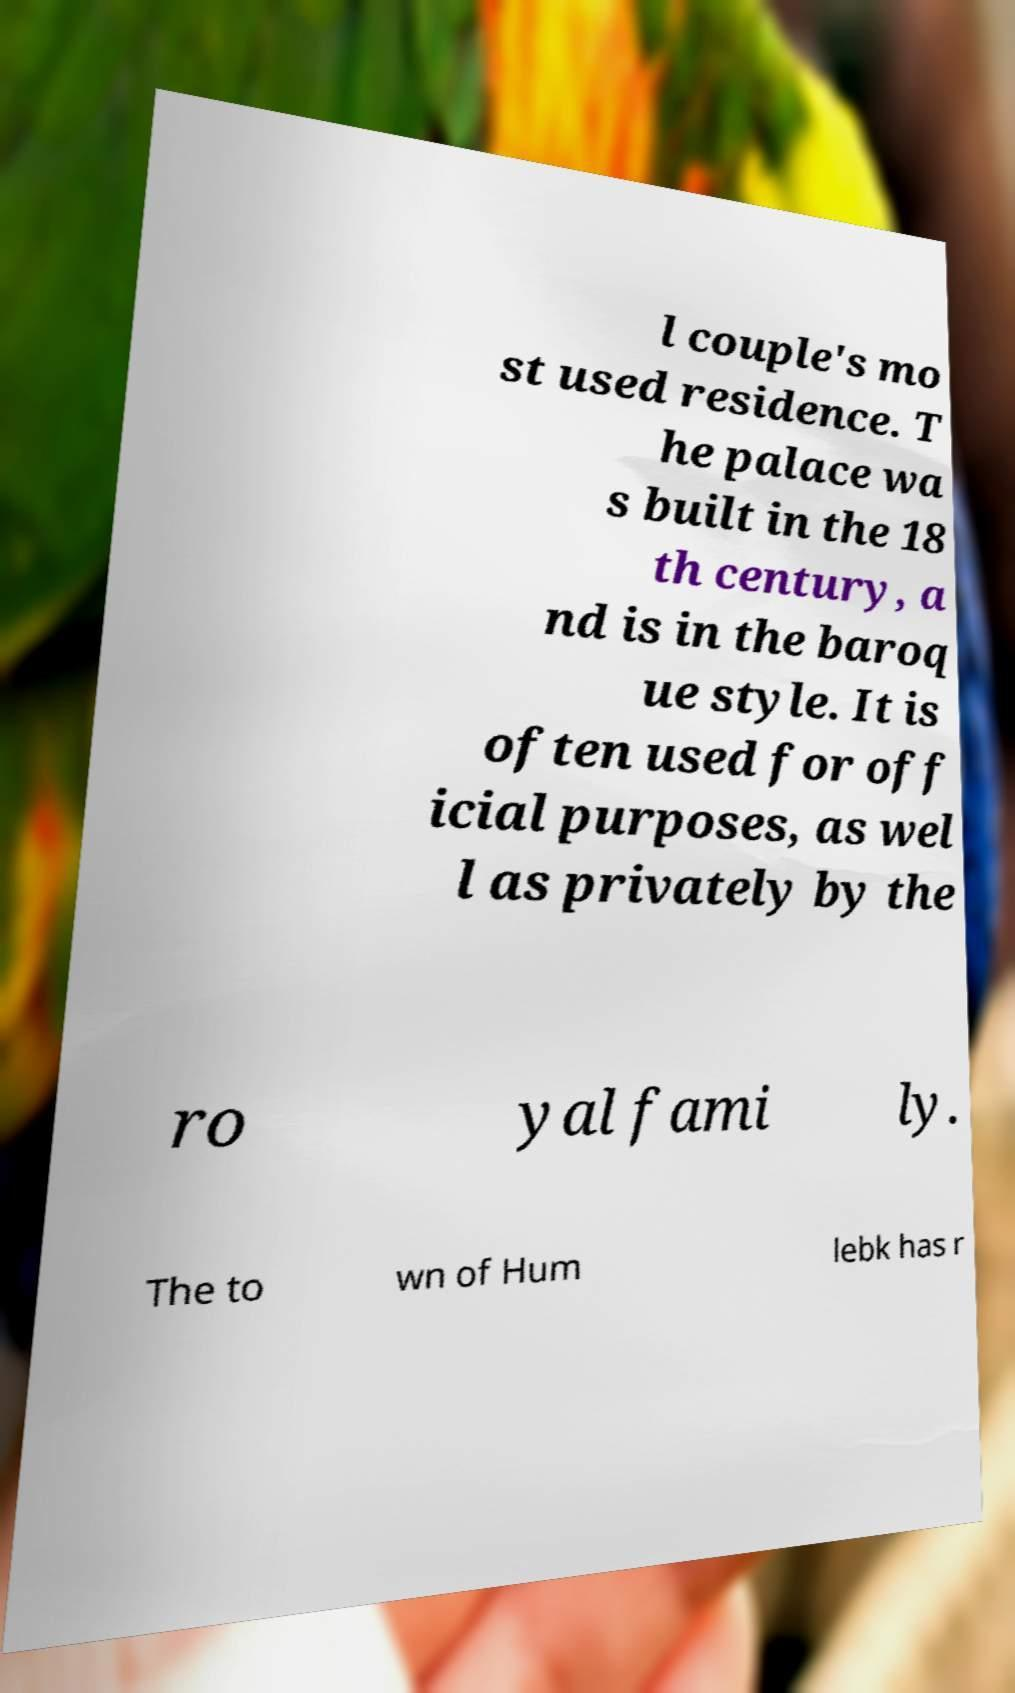For documentation purposes, I need the text within this image transcribed. Could you provide that? l couple's mo st used residence. T he palace wa s built in the 18 th century, a nd is in the baroq ue style. It is often used for off icial purposes, as wel l as privately by the ro yal fami ly. The to wn of Hum lebk has r 